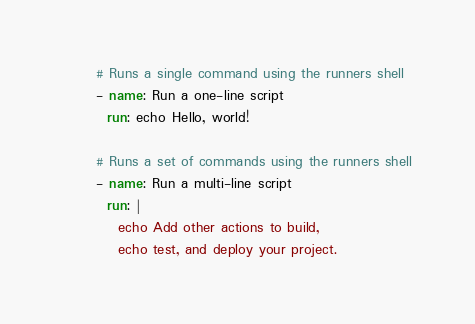<code> <loc_0><loc_0><loc_500><loc_500><_YAML_>
      # Runs a single command using the runners shell
      - name: Run a one-line script
        run: echo Hello, world!

      # Runs a set of commands using the runners shell
      - name: Run a multi-line script
        run: |
          echo Add other actions to build,
          echo test, and deploy your project.
</code> 